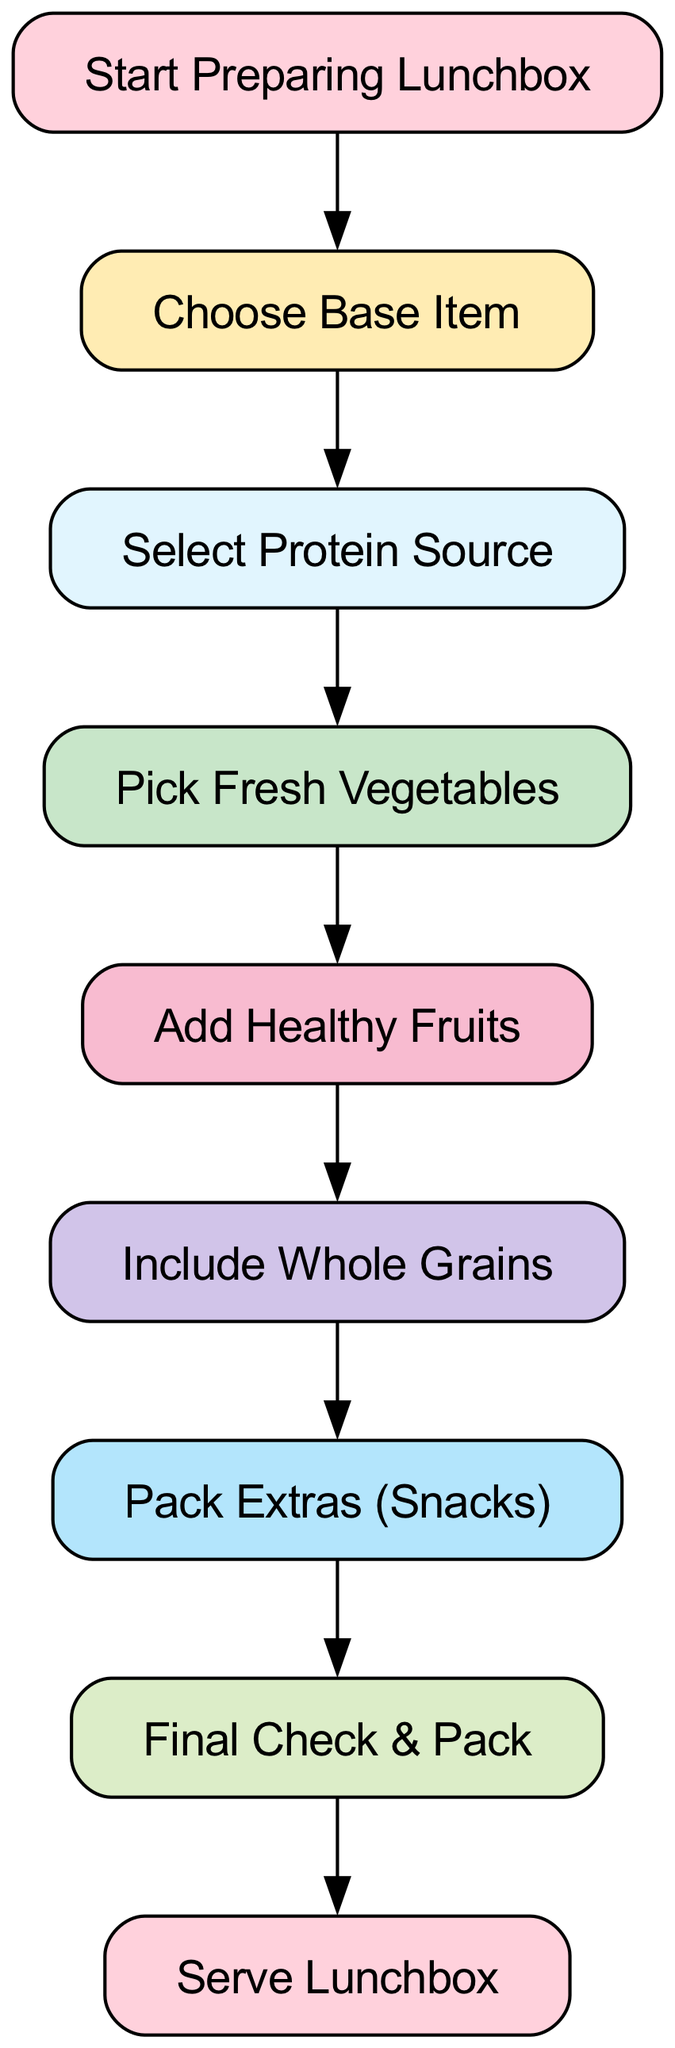What is the first step in preparing the lunchbox? According to the diagram, the first step is labeled "Start Preparing Lunchbox." This node is directly connected to the next step, indicating it is the starting point of the process.
Answer: Start Preparing Lunchbox How many nodes are there in the diagram? The diagram includes a total of 9 nodes, each representing a step in the lunchbox preparation process. Counting through the nodes listed, we find nine distinct entries.
Answer: 9 What step comes after "Add Healthy Fruits"? The diagram shows that after "Add Healthy Fruits," the next step is "Include Whole Grains." The connection between these two nodes indicates this sequence in the preparation process.
Answer: Include Whole Grains Which step directly precedes "Serve Lunchbox"? The step that directly precedes "Serve Lunchbox" is "Final Check & Pack." Therefore, completing the final check is essential before serving the lunchbox.
Answer: Final Check & Pack What is the relationship between "Choose Base Item" and "Select Protein Source"? The relationship between "Choose Base Item" and "Select Protein Source" indicates that you must choose a base item before moving on to select the protein source. This is a sequential relationship where one step leads to the next.
Answer: Sequential relationship How many edges connect the nodes in the diagram? By examining the diagram, we find that there are 8 edges that connect the 9 nodes, illustrating the flow from one preparation step to the next. Each edge indicates a directional relationship between two steps.
Answer: 8 What is the last step before packing extras? The last step before "Pack Extras (Snacks)" is "Include Whole Grains." This step must be completed before moving on to packing any additional snacks.
Answer: Include Whole Grains What is the flow of the diagram from "Select Protein Source" to "Pack Extras"? The flow starts at "Select Protein Source," moving to "Pick Fresh Vegetables," then to "Add Healthy Fruits," continuing to "Include Whole Grains," and finally leading to "Pack Extras." This series shows the necessary steps in the preparation process after selecting the protein.
Answer: Select Protein Source → Pick Fresh Vegetables → Add Healthy Fruits → Include Whole Grains → Pack Extras How does the directed graph format benefit the understanding of lunchbox preparation steps? The directed graph format clearly shows the process flow in a sequential manner, allowing easy visualization of each step and its dependencies. This makes it straightforward to understand which steps must be completed in order before progressing to the next one.
Answer: Clear visualization of process flow 